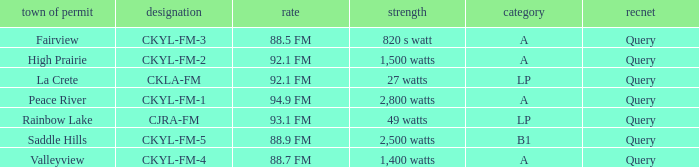What is the identifier for the 9 CKYL-FM-1. 